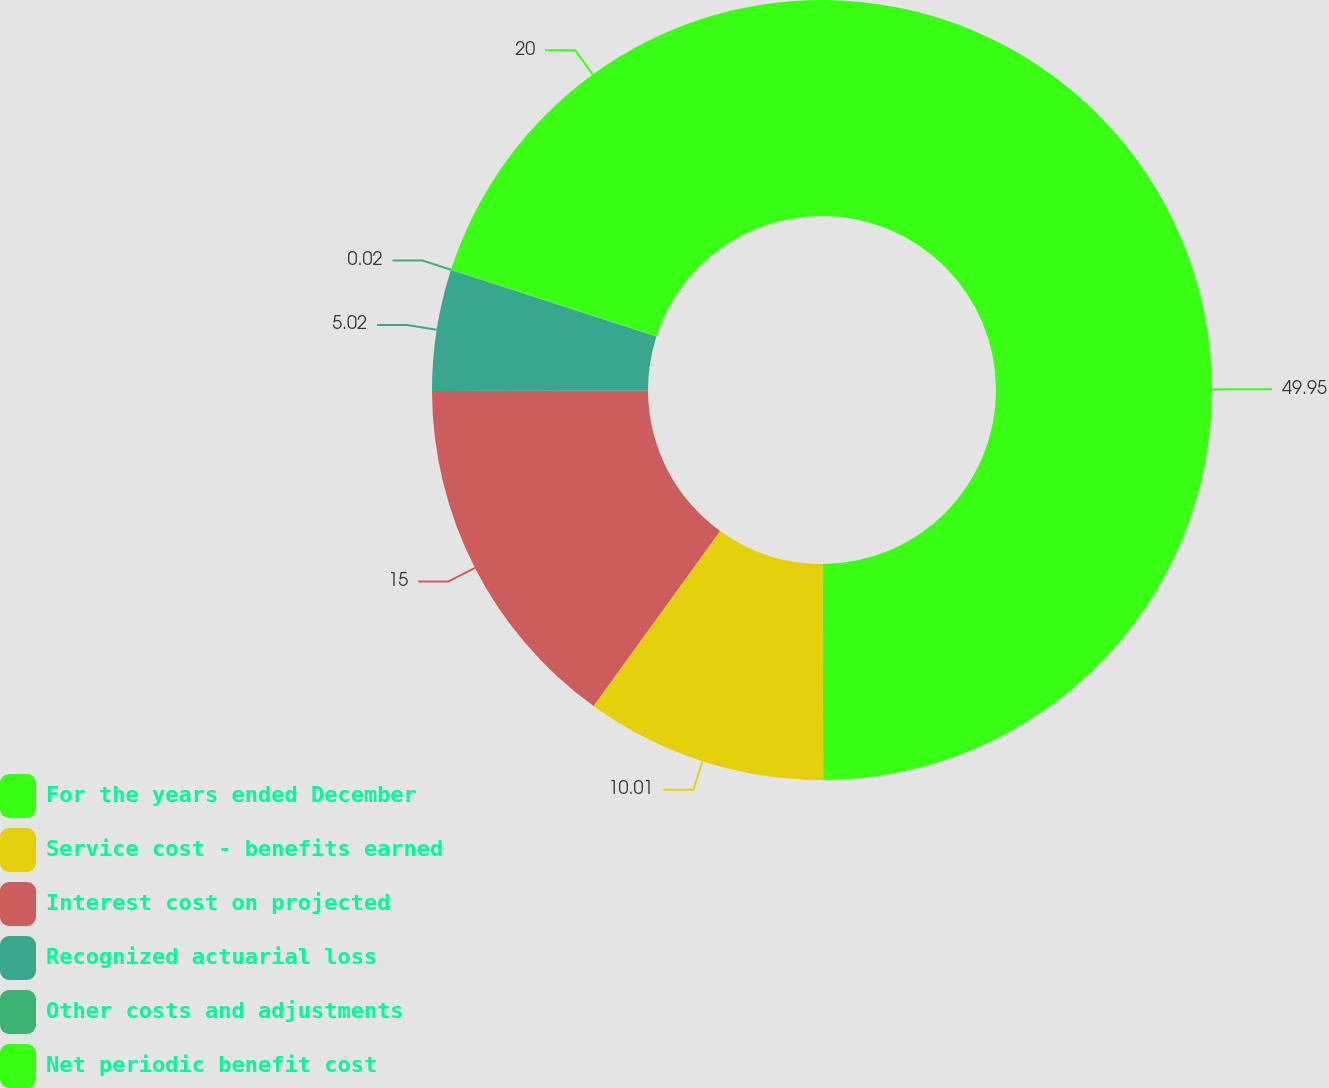Convert chart to OTSL. <chart><loc_0><loc_0><loc_500><loc_500><pie_chart><fcel>For the years ended December<fcel>Service cost - benefits earned<fcel>Interest cost on projected<fcel>Recognized actuarial loss<fcel>Other costs and adjustments<fcel>Net periodic benefit cost<nl><fcel>49.95%<fcel>10.01%<fcel>15.0%<fcel>5.02%<fcel>0.02%<fcel>20.0%<nl></chart> 